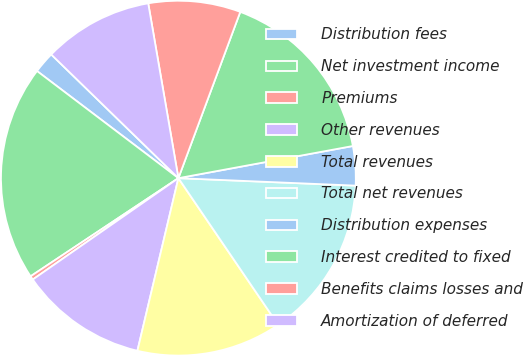Convert chart. <chart><loc_0><loc_0><loc_500><loc_500><pie_chart><fcel>Distribution fees<fcel>Net investment income<fcel>Premiums<fcel>Other revenues<fcel>Total revenues<fcel>Total net revenues<fcel>Distribution expenses<fcel>Interest credited to fixed<fcel>Benefits claims losses and<fcel>Amortization of deferred<nl><fcel>1.96%<fcel>19.65%<fcel>0.35%<fcel>11.61%<fcel>13.22%<fcel>14.82%<fcel>3.57%<fcel>16.43%<fcel>8.39%<fcel>10.0%<nl></chart> 